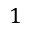<formula> <loc_0><loc_0><loc_500><loc_500>1</formula> 